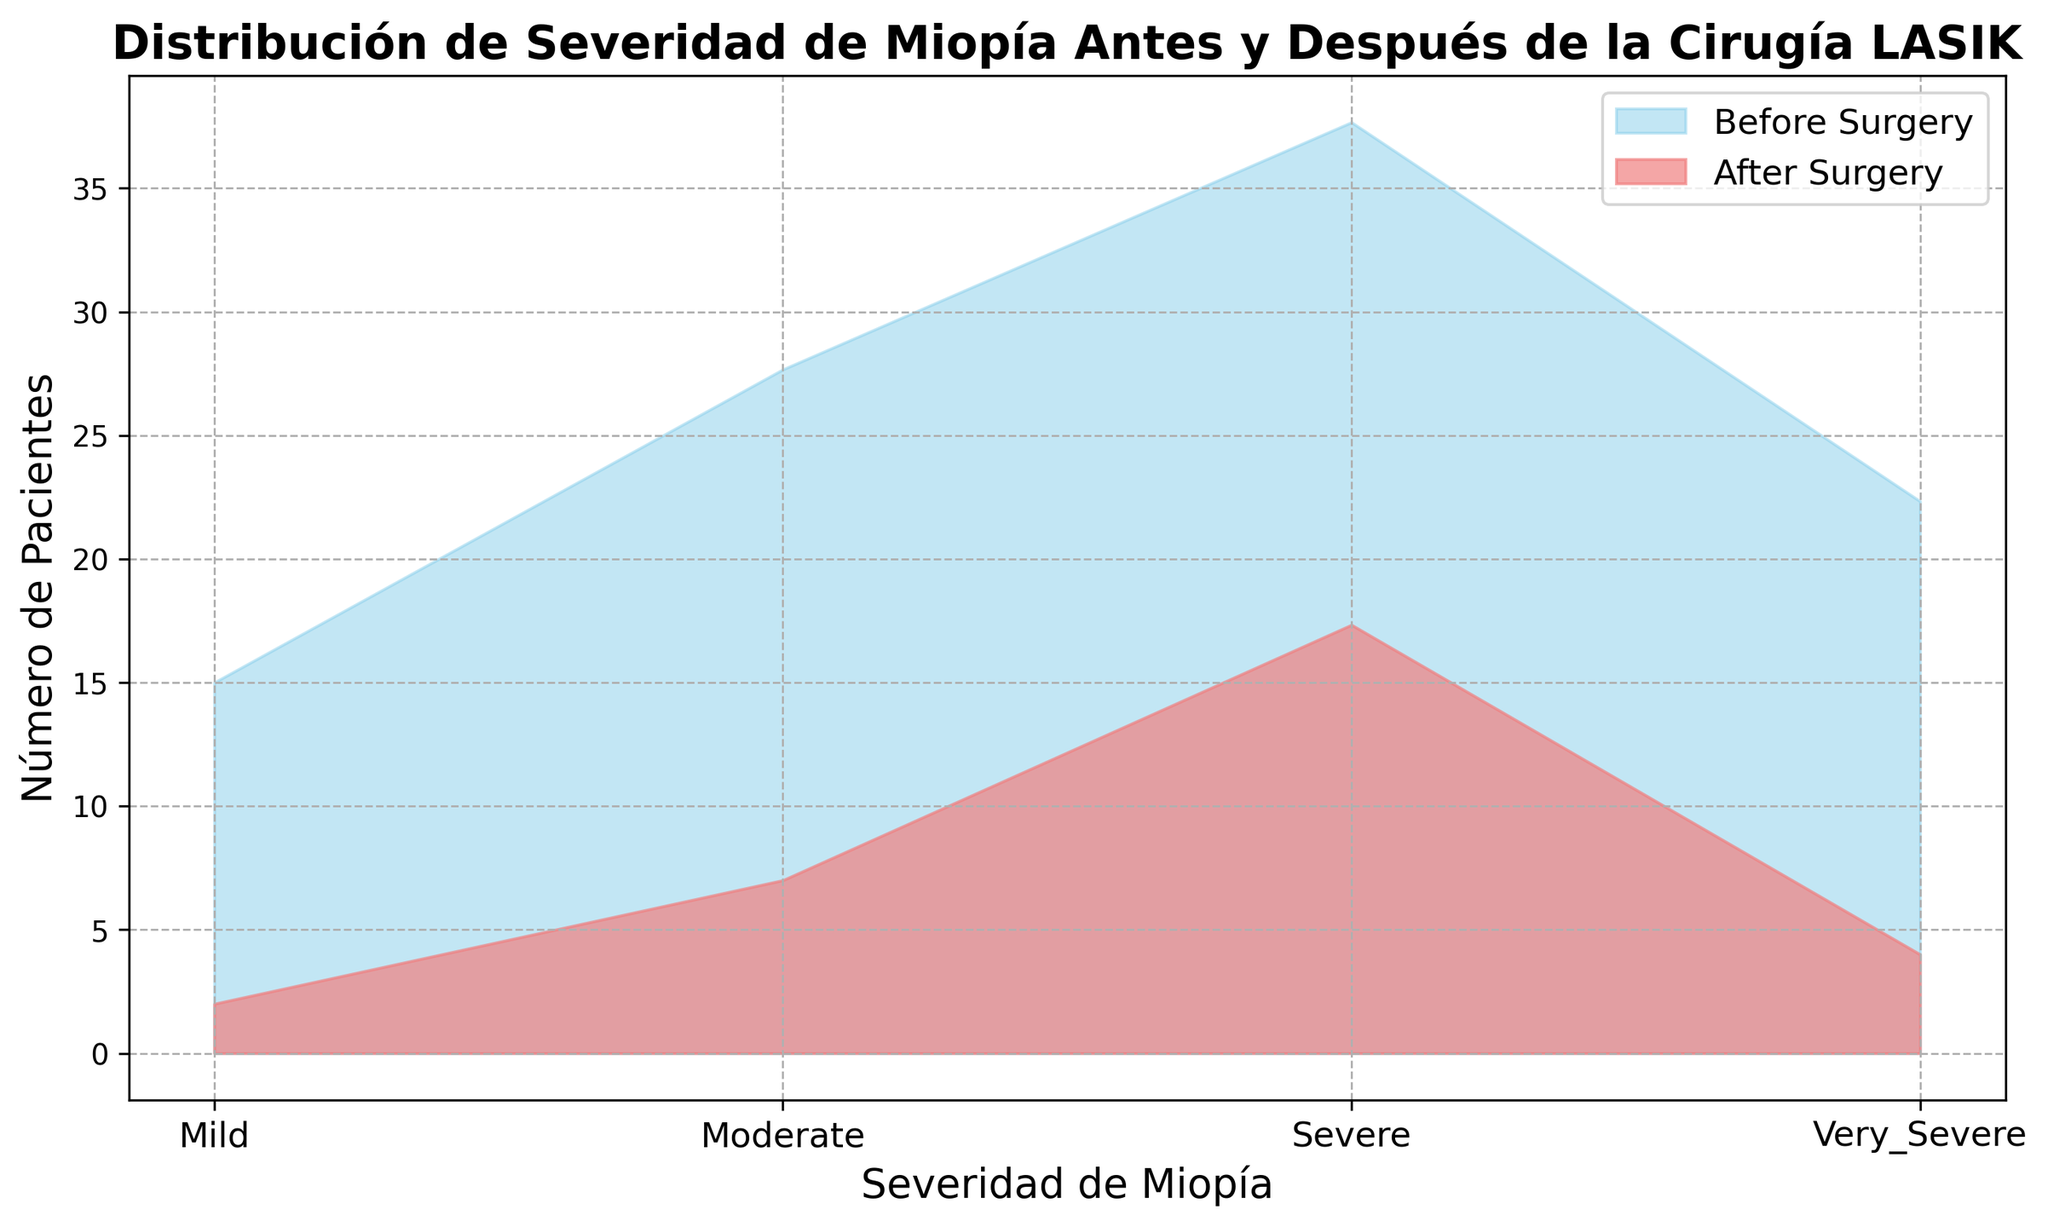¿Cuál es la categoría con mayor número de pacientes antes de la cirugía? Observando la gráfica, la categoría de Severidad de Miopía más alta antes de la cirugía es la que tiene el área de color azul más grande. Esa categoría es 'Severe'.
Answer: Severe ¿Cuánto disminuyó la categoría 'Very Severe' en número de pacientes después de la cirugía? Observando los valores promedio antes y después de la cirugía para 'Very Severe', antes es aproximadamente 22.33 y después es aproximadamente 4.00. La diferencia es 22.33 - 4.00 = 18.33.
Answer: 18.33 ¿Cuál es la categoría que mostró la mayor reducción en la cantidad de pacientes después de la cirugía? Comparando las diferencias entre los valores antes y después de la cirugía para cada categoría, la categoría con la mayor diferencia es 'Severe'.
Answer: Severe Comparando las categorías 'Mild' y 'Moderate', ¿cuál tuvo una mayor reducción en el número de pacientes después de la cirugía? Observando los valores promedio antes y después de la cirugía para 'Mild', antes es 15 y después es 2. Para 'Moderate', antes es 27.67 y después es 7. Comparando las diferencias: Mild es 13 y Moderate es 20.67.
Answer: Moderate ¿Cuál es la categoría con menos pacientes después de la cirugía? Observando la gráfica, la categoría con el área de color rojo más pequeña es 'Mild'.
Answer: Mild ¿Cuál es la suma total de pacientes antes de la cirugía en todas las categorías? Sumar los valores promedio antes de la cirugía para todas las categorías: Mild (15), Moderate (27.67), Severe (37.67), Very Severe (22.33). La suma es 15 + 27.67 + 37.67 + 22.33 = 102.67.
Answer: 102.67 ¿Cómo se compara la cantidad de pacientes en la categoría 'Severe' antes y después de la cirugía? Observando la gráfica, la categoría 'Severe' tiene un área azul de 37.67 y un área roja de 17. La diferencia es 37.67 - 17 = 20.67 menos pacientes.
Answer: 20.67 menos pacientes ¿Cuál es el porcentaje de pacientes en la categoría 'Moderate' que se mantiene después de la cirugía en comparación con el número inicial? El número de pacientes en 'Moderate' antes de la cirugía es aproximadamente 27.67 y después es 7. El porcentaje es (7 / 27.67) * 100 = 25.3%.
Answer: 25.3% 